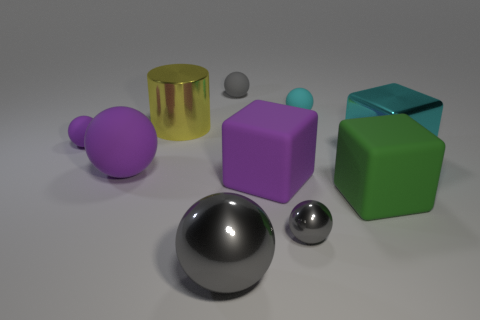How many gray spheres must be subtracted to get 1 gray spheres? 2 Subtract all blue cubes. How many gray balls are left? 3 Subtract all cyan balls. How many balls are left? 5 Subtract all large spheres. How many spheres are left? 4 Subtract 4 spheres. How many spheres are left? 2 Subtract all brown spheres. Subtract all cyan cubes. How many spheres are left? 6 Subtract all cylinders. How many objects are left? 9 Subtract all gray rubber spheres. Subtract all small purple things. How many objects are left? 8 Add 6 green rubber things. How many green rubber things are left? 7 Add 6 tiny green metal balls. How many tiny green metal balls exist? 6 